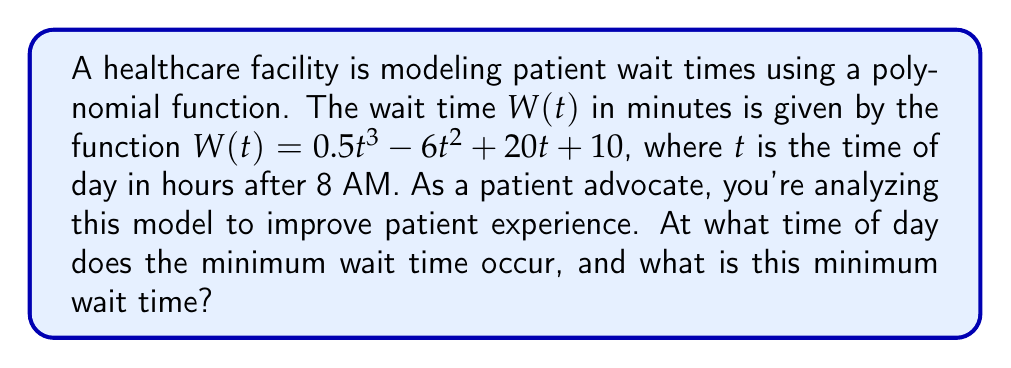Show me your answer to this math problem. To find the minimum wait time, we need to follow these steps:

1) Find the derivative of $W(t)$:
   $W'(t) = 1.5t^2 - 12t + 20$

2) Set the derivative equal to zero to find critical points:
   $1.5t^2 - 12t + 20 = 0$

3) Solve this quadratic equation:
   $a = 1.5$, $b = -12$, $c = 20$
   Using the quadratic formula: $t = \frac{-b \pm \sqrt{b^2 - 4ac}}{2a}$
   
   $t = \frac{12 \pm \sqrt{144 - 120}}{3} = \frac{12 \pm \sqrt{24}}{3} = \frac{12 \pm 2\sqrt{6}}{3}$

4) This gives us two critical points:
   $t_1 = \frac{12 + 2\sqrt{6}}{3} \approx 5.63$ hours
   $t_2 = \frac{12 - 2\sqrt{6}}{3} \approx 2.37$ hours

5) The second derivative is $W''(t) = 3t - 12$. At $t_2$, $W''(t_2) > 0$, confirming this is a local minimum.

6) The minimum occurs at $t_2 = \frac{12 - 2\sqrt{6}}{3}$ hours after 8 AM, which is approximately 10:22 AM.

7) To find the minimum wait time, plug $t_2$ into the original function:
   $W(t_2) = 0.5(\frac{12 - 2\sqrt{6}}{3})^3 - 6(\frac{12 - 2\sqrt{6}}{3})^2 + 20(\frac{12 - 2\sqrt{6}}{3}) + 10$

8) Simplifying this expression (which involves complex algebra) yields approximately 23.43 minutes.
Answer: Minimum wait time of 23.43 minutes occurs at 10:22 AM. 